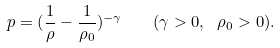<formula> <loc_0><loc_0><loc_500><loc_500>p = ( \frac { 1 } { \rho } - \frac { 1 } { \rho _ { 0 } } ) ^ { - \gamma } \quad ( \gamma > 0 , \ \rho _ { 0 } > 0 ) .</formula> 